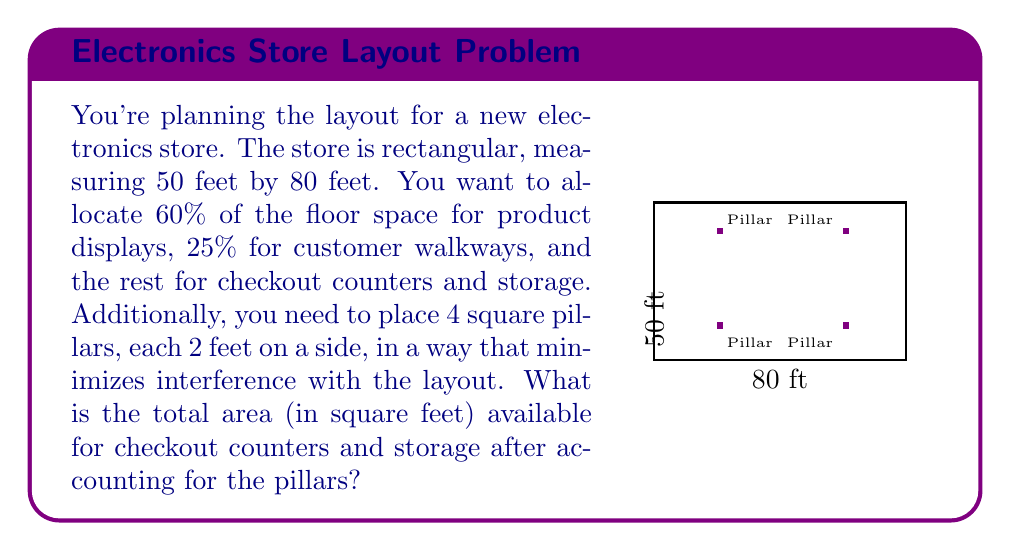Help me with this question. Let's break this down step-by-step:

1) Calculate the total floor area:
   $$ \text{Total Area} = 50 \text{ ft} \times 80 \text{ ft} = 4000 \text{ sq ft} $$

2) Calculate the area taken by the pillars:
   $$ \text{Pillar Area} = 4 \times (2 \text{ ft} \times 2 \text{ ft}) = 16 \text{ sq ft} $$

3) Calculate the actual usable area:
   $$ \text{Usable Area} = 4000 \text{ sq ft} - 16 \text{ sq ft} = 3984 \text{ sq ft} $$

4) Calculate the areas for different sections:
   - Product displays (60%): $3984 \times 0.60 = 2390.4 \text{ sq ft}$
   - Customer walkways (25%): $3984 \times 0.25 = 996 \text{ sq ft}$
   - Remaining for checkout and storage: $3984 - 2390.4 - 996 = 597.6 \text{ sq ft}$

Therefore, the area available for checkout counters and storage is 597.6 sq ft.
Answer: 597.6 sq ft 